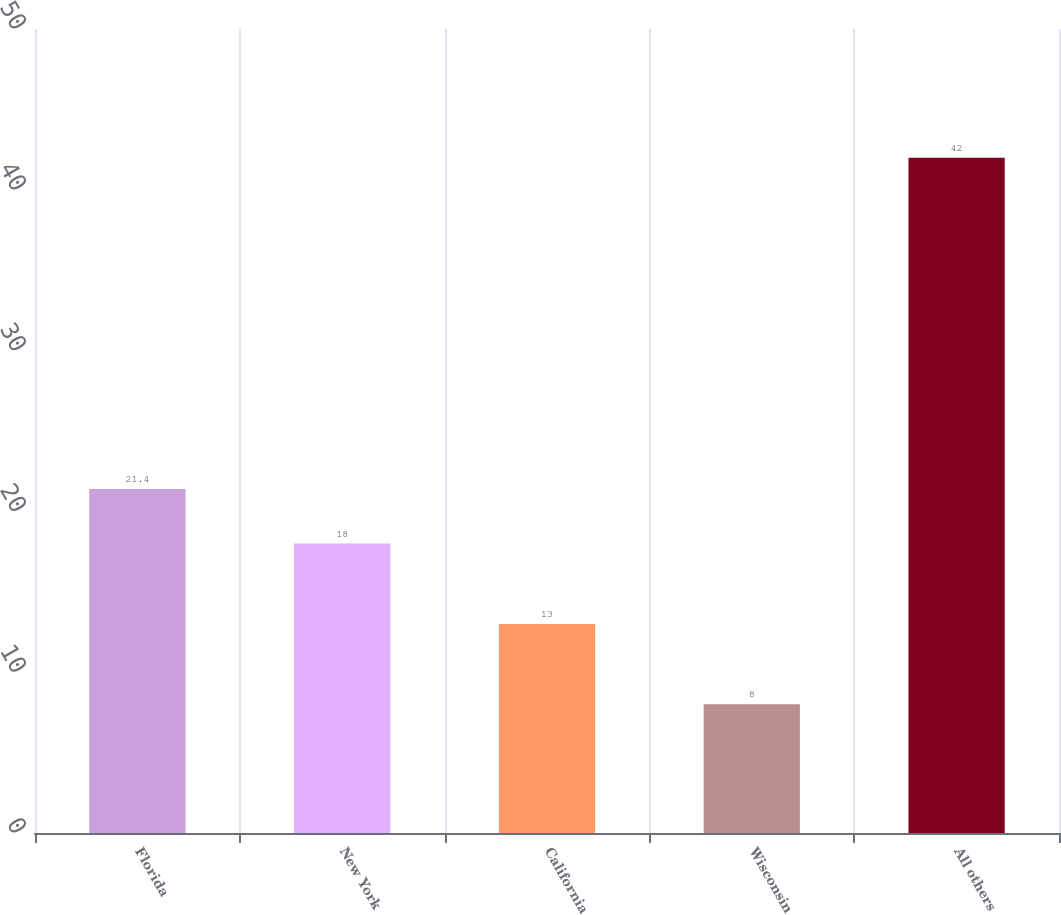<chart> <loc_0><loc_0><loc_500><loc_500><bar_chart><fcel>Florida<fcel>New York<fcel>California<fcel>Wisconsin<fcel>All others<nl><fcel>21.4<fcel>18<fcel>13<fcel>8<fcel>42<nl></chart> 